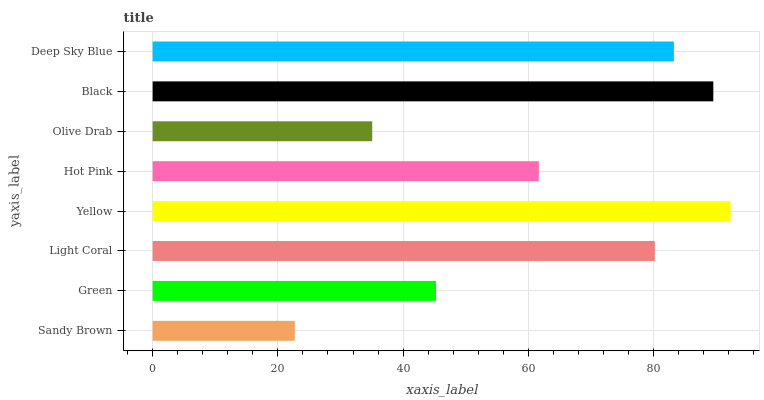Is Sandy Brown the minimum?
Answer yes or no. Yes. Is Yellow the maximum?
Answer yes or no. Yes. Is Green the minimum?
Answer yes or no. No. Is Green the maximum?
Answer yes or no. No. Is Green greater than Sandy Brown?
Answer yes or no. Yes. Is Sandy Brown less than Green?
Answer yes or no. Yes. Is Sandy Brown greater than Green?
Answer yes or no. No. Is Green less than Sandy Brown?
Answer yes or no. No. Is Light Coral the high median?
Answer yes or no. Yes. Is Hot Pink the low median?
Answer yes or no. Yes. Is Yellow the high median?
Answer yes or no. No. Is Black the low median?
Answer yes or no. No. 